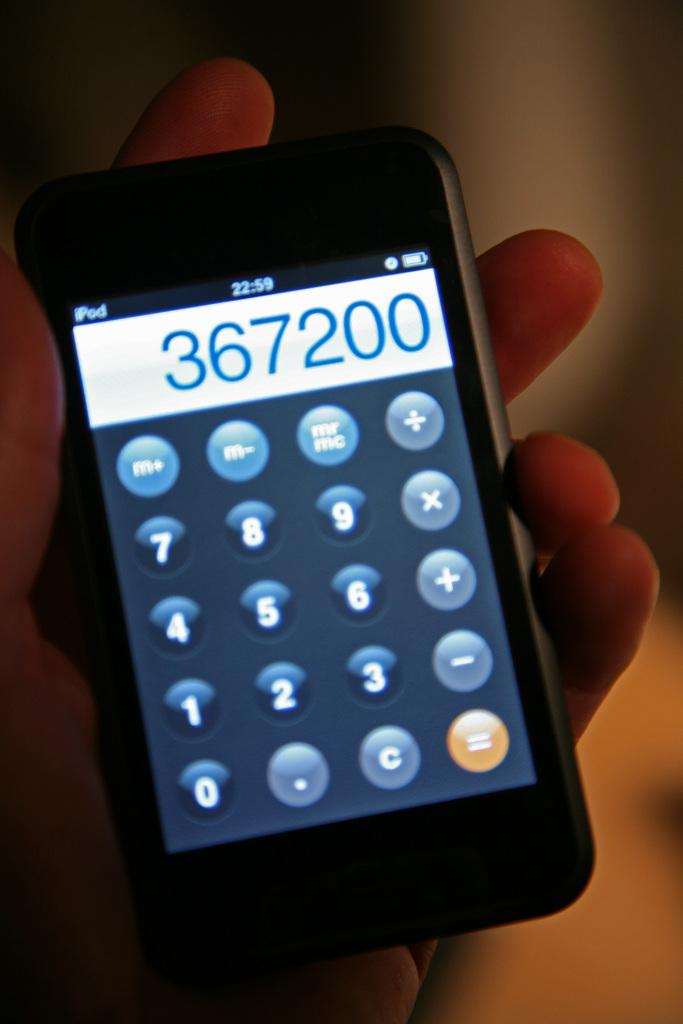<image>
Share a concise interpretation of the image provided. An iPod displays a calculator with the number 367200 at the top. 